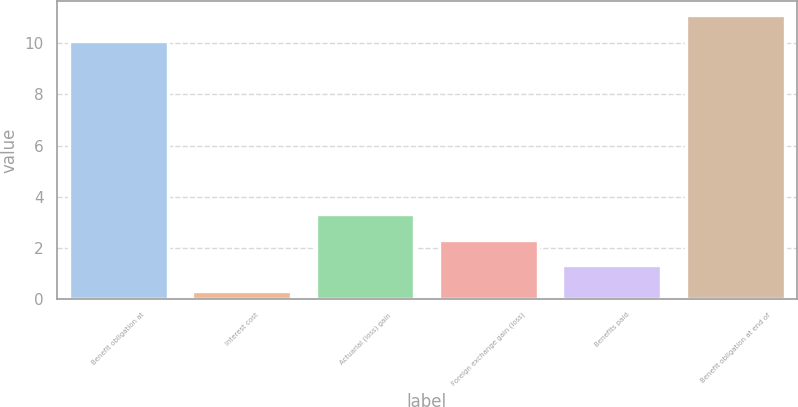<chart> <loc_0><loc_0><loc_500><loc_500><bar_chart><fcel>Benefit obligation at<fcel>Interest cost<fcel>Actuarial (loss) gain<fcel>Foreign exchange gain (loss)<fcel>Benefits paid<fcel>Benefit obligation at end of<nl><fcel>10.1<fcel>0.3<fcel>3.3<fcel>2.3<fcel>1.3<fcel>11.1<nl></chart> 